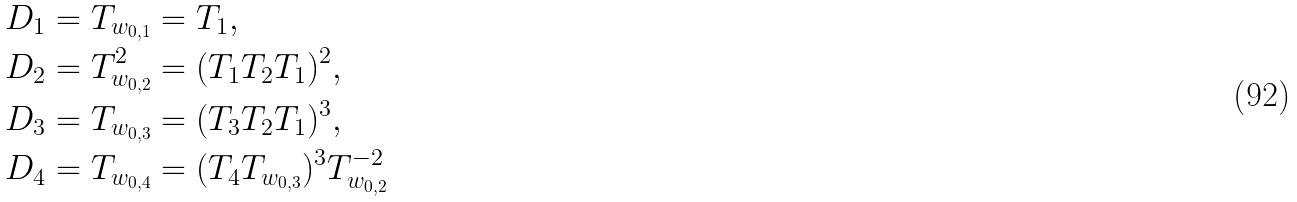<formula> <loc_0><loc_0><loc_500><loc_500>D _ { 1 } & = T _ { w _ { 0 , 1 } } = T _ { 1 } , \\ D _ { 2 } & = T _ { w _ { 0 , 2 } } ^ { 2 } = ( T _ { 1 } T _ { 2 } T _ { 1 } ) ^ { 2 } , \\ D _ { 3 } & = T _ { w _ { 0 , 3 } } = ( T _ { 3 } T _ { 2 } T _ { 1 } ) ^ { 3 } , \\ D _ { 4 } & = T _ { w _ { 0 , 4 } } = ( T _ { 4 } T _ { w _ { 0 , 3 } } ) ^ { 3 } T _ { w _ { 0 , 2 } } ^ { - 2 }</formula> 